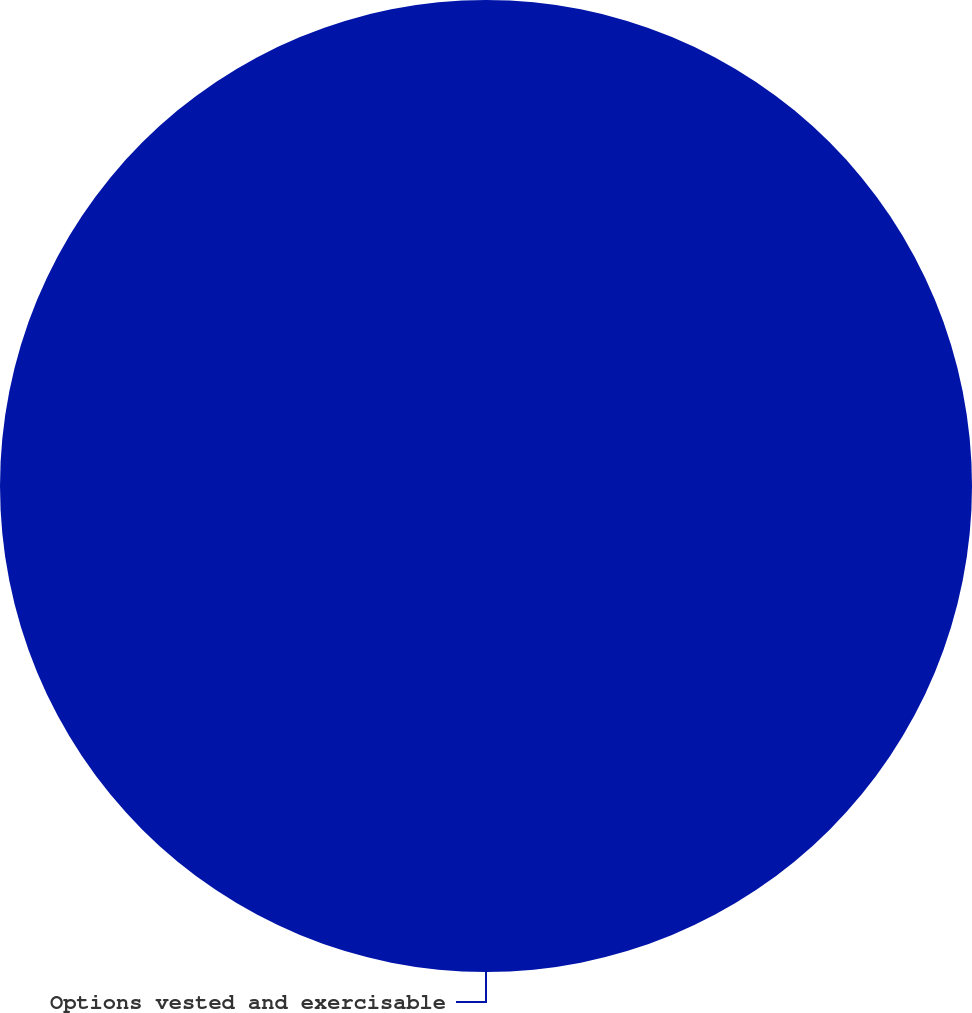Convert chart. <chart><loc_0><loc_0><loc_500><loc_500><pie_chart><fcel>Options vested and exercisable<nl><fcel>100.0%<nl></chart> 